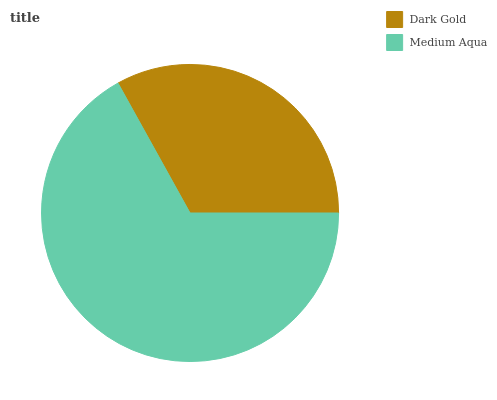Is Dark Gold the minimum?
Answer yes or no. Yes. Is Medium Aqua the maximum?
Answer yes or no. Yes. Is Medium Aqua the minimum?
Answer yes or no. No. Is Medium Aqua greater than Dark Gold?
Answer yes or no. Yes. Is Dark Gold less than Medium Aqua?
Answer yes or no. Yes. Is Dark Gold greater than Medium Aqua?
Answer yes or no. No. Is Medium Aqua less than Dark Gold?
Answer yes or no. No. Is Medium Aqua the high median?
Answer yes or no. Yes. Is Dark Gold the low median?
Answer yes or no. Yes. Is Dark Gold the high median?
Answer yes or no. No. Is Medium Aqua the low median?
Answer yes or no. No. 